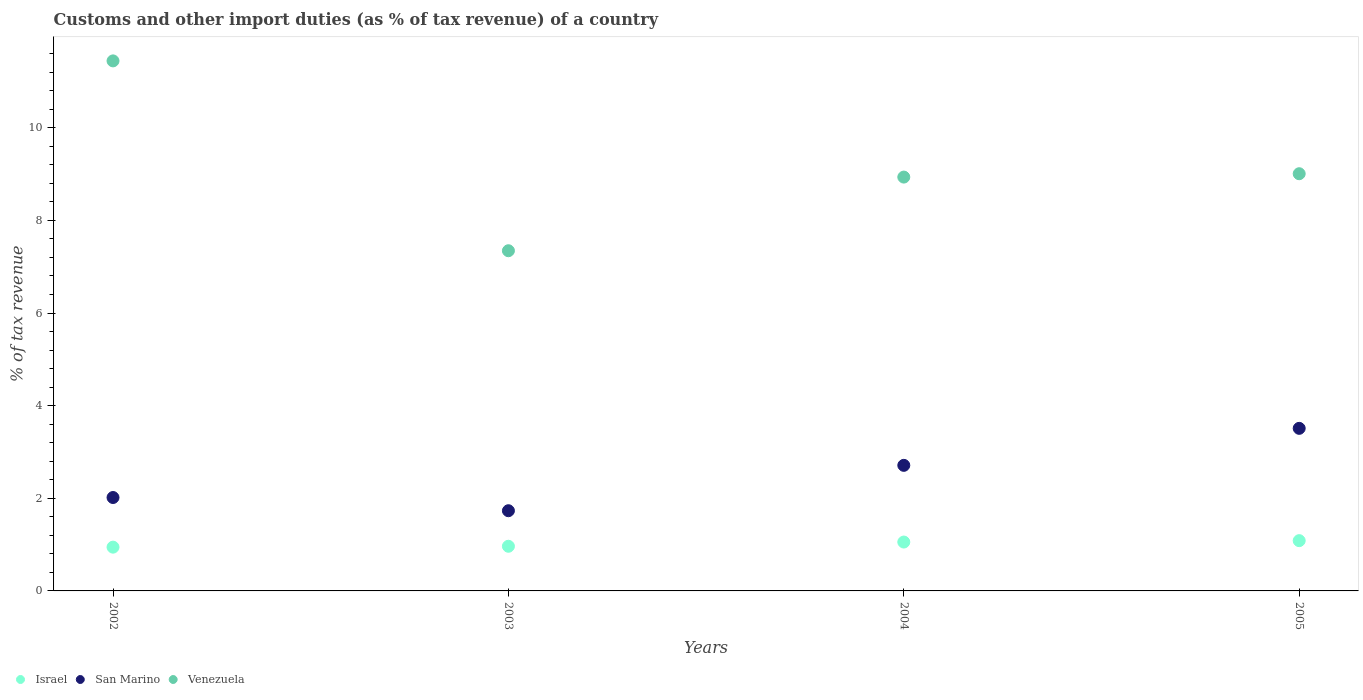What is the percentage of tax revenue from customs in Venezuela in 2005?
Your answer should be very brief. 9.01. Across all years, what is the maximum percentage of tax revenue from customs in Venezuela?
Keep it short and to the point. 11.44. Across all years, what is the minimum percentage of tax revenue from customs in San Marino?
Offer a very short reply. 1.73. What is the total percentage of tax revenue from customs in San Marino in the graph?
Offer a terse response. 9.97. What is the difference between the percentage of tax revenue from customs in Venezuela in 2002 and that in 2005?
Your answer should be compact. 2.44. What is the difference between the percentage of tax revenue from customs in San Marino in 2004 and the percentage of tax revenue from customs in Venezuela in 2002?
Provide a succinct answer. -8.73. What is the average percentage of tax revenue from customs in San Marino per year?
Keep it short and to the point. 2.49. In the year 2004, what is the difference between the percentage of tax revenue from customs in San Marino and percentage of tax revenue from customs in Venezuela?
Make the answer very short. -6.22. In how many years, is the percentage of tax revenue from customs in Venezuela greater than 6.4 %?
Provide a succinct answer. 4. What is the ratio of the percentage of tax revenue from customs in Venezuela in 2002 to that in 2005?
Ensure brevity in your answer.  1.27. What is the difference between the highest and the second highest percentage of tax revenue from customs in Venezuela?
Provide a succinct answer. 2.44. What is the difference between the highest and the lowest percentage of tax revenue from customs in Venezuela?
Your answer should be compact. 4.1. How many years are there in the graph?
Offer a very short reply. 4. What is the difference between two consecutive major ticks on the Y-axis?
Provide a short and direct response. 2. Are the values on the major ticks of Y-axis written in scientific E-notation?
Offer a very short reply. No. What is the title of the graph?
Make the answer very short. Customs and other import duties (as % of tax revenue) of a country. Does "Middle East & North Africa (developing only)" appear as one of the legend labels in the graph?
Your answer should be very brief. No. What is the label or title of the X-axis?
Your response must be concise. Years. What is the label or title of the Y-axis?
Keep it short and to the point. % of tax revenue. What is the % of tax revenue of Israel in 2002?
Keep it short and to the point. 0.95. What is the % of tax revenue of San Marino in 2002?
Provide a short and direct response. 2.02. What is the % of tax revenue in Venezuela in 2002?
Offer a very short reply. 11.44. What is the % of tax revenue in Israel in 2003?
Make the answer very short. 0.96. What is the % of tax revenue in San Marino in 2003?
Make the answer very short. 1.73. What is the % of tax revenue of Venezuela in 2003?
Offer a very short reply. 7.35. What is the % of tax revenue of Israel in 2004?
Provide a short and direct response. 1.06. What is the % of tax revenue of San Marino in 2004?
Offer a terse response. 2.71. What is the % of tax revenue in Venezuela in 2004?
Your answer should be compact. 8.94. What is the % of tax revenue of Israel in 2005?
Your response must be concise. 1.09. What is the % of tax revenue in San Marino in 2005?
Keep it short and to the point. 3.51. What is the % of tax revenue of Venezuela in 2005?
Offer a terse response. 9.01. Across all years, what is the maximum % of tax revenue of Israel?
Ensure brevity in your answer.  1.09. Across all years, what is the maximum % of tax revenue of San Marino?
Provide a short and direct response. 3.51. Across all years, what is the maximum % of tax revenue of Venezuela?
Offer a terse response. 11.44. Across all years, what is the minimum % of tax revenue in Israel?
Your answer should be compact. 0.95. Across all years, what is the minimum % of tax revenue in San Marino?
Offer a terse response. 1.73. Across all years, what is the minimum % of tax revenue of Venezuela?
Provide a short and direct response. 7.35. What is the total % of tax revenue in Israel in the graph?
Make the answer very short. 4.05. What is the total % of tax revenue of San Marino in the graph?
Your response must be concise. 9.97. What is the total % of tax revenue of Venezuela in the graph?
Offer a very short reply. 36.73. What is the difference between the % of tax revenue of Israel in 2002 and that in 2003?
Your response must be concise. -0.02. What is the difference between the % of tax revenue of San Marino in 2002 and that in 2003?
Your answer should be compact. 0.29. What is the difference between the % of tax revenue of Venezuela in 2002 and that in 2003?
Your answer should be very brief. 4.1. What is the difference between the % of tax revenue of Israel in 2002 and that in 2004?
Ensure brevity in your answer.  -0.11. What is the difference between the % of tax revenue in San Marino in 2002 and that in 2004?
Provide a short and direct response. -0.69. What is the difference between the % of tax revenue in Venezuela in 2002 and that in 2004?
Your response must be concise. 2.51. What is the difference between the % of tax revenue in Israel in 2002 and that in 2005?
Your answer should be very brief. -0.14. What is the difference between the % of tax revenue of San Marino in 2002 and that in 2005?
Make the answer very short. -1.49. What is the difference between the % of tax revenue in Venezuela in 2002 and that in 2005?
Keep it short and to the point. 2.44. What is the difference between the % of tax revenue of Israel in 2003 and that in 2004?
Keep it short and to the point. -0.09. What is the difference between the % of tax revenue in San Marino in 2003 and that in 2004?
Provide a succinct answer. -0.98. What is the difference between the % of tax revenue in Venezuela in 2003 and that in 2004?
Ensure brevity in your answer.  -1.59. What is the difference between the % of tax revenue in Israel in 2003 and that in 2005?
Your response must be concise. -0.12. What is the difference between the % of tax revenue in San Marino in 2003 and that in 2005?
Provide a succinct answer. -1.78. What is the difference between the % of tax revenue of Venezuela in 2003 and that in 2005?
Ensure brevity in your answer.  -1.66. What is the difference between the % of tax revenue of Israel in 2004 and that in 2005?
Offer a very short reply. -0.03. What is the difference between the % of tax revenue in San Marino in 2004 and that in 2005?
Provide a short and direct response. -0.8. What is the difference between the % of tax revenue in Venezuela in 2004 and that in 2005?
Ensure brevity in your answer.  -0.07. What is the difference between the % of tax revenue of Israel in 2002 and the % of tax revenue of San Marino in 2003?
Your answer should be compact. -0.79. What is the difference between the % of tax revenue of Israel in 2002 and the % of tax revenue of Venezuela in 2003?
Your response must be concise. -6.4. What is the difference between the % of tax revenue of San Marino in 2002 and the % of tax revenue of Venezuela in 2003?
Your answer should be very brief. -5.33. What is the difference between the % of tax revenue of Israel in 2002 and the % of tax revenue of San Marino in 2004?
Offer a terse response. -1.77. What is the difference between the % of tax revenue of Israel in 2002 and the % of tax revenue of Venezuela in 2004?
Offer a very short reply. -7.99. What is the difference between the % of tax revenue of San Marino in 2002 and the % of tax revenue of Venezuela in 2004?
Your answer should be compact. -6.92. What is the difference between the % of tax revenue in Israel in 2002 and the % of tax revenue in San Marino in 2005?
Make the answer very short. -2.57. What is the difference between the % of tax revenue in Israel in 2002 and the % of tax revenue in Venezuela in 2005?
Give a very brief answer. -8.06. What is the difference between the % of tax revenue in San Marino in 2002 and the % of tax revenue in Venezuela in 2005?
Keep it short and to the point. -6.99. What is the difference between the % of tax revenue of Israel in 2003 and the % of tax revenue of San Marino in 2004?
Offer a terse response. -1.75. What is the difference between the % of tax revenue in Israel in 2003 and the % of tax revenue in Venezuela in 2004?
Your response must be concise. -7.97. What is the difference between the % of tax revenue of San Marino in 2003 and the % of tax revenue of Venezuela in 2004?
Offer a very short reply. -7.2. What is the difference between the % of tax revenue of Israel in 2003 and the % of tax revenue of San Marino in 2005?
Offer a very short reply. -2.55. What is the difference between the % of tax revenue in Israel in 2003 and the % of tax revenue in Venezuela in 2005?
Provide a short and direct response. -8.04. What is the difference between the % of tax revenue of San Marino in 2003 and the % of tax revenue of Venezuela in 2005?
Your answer should be very brief. -7.28. What is the difference between the % of tax revenue of Israel in 2004 and the % of tax revenue of San Marino in 2005?
Make the answer very short. -2.46. What is the difference between the % of tax revenue in Israel in 2004 and the % of tax revenue in Venezuela in 2005?
Provide a succinct answer. -7.95. What is the difference between the % of tax revenue of San Marino in 2004 and the % of tax revenue of Venezuela in 2005?
Keep it short and to the point. -6.3. What is the average % of tax revenue of Israel per year?
Keep it short and to the point. 1.01. What is the average % of tax revenue in San Marino per year?
Offer a very short reply. 2.49. What is the average % of tax revenue of Venezuela per year?
Provide a succinct answer. 9.18. In the year 2002, what is the difference between the % of tax revenue of Israel and % of tax revenue of San Marino?
Keep it short and to the point. -1.07. In the year 2002, what is the difference between the % of tax revenue in Israel and % of tax revenue in Venezuela?
Your answer should be compact. -10.5. In the year 2002, what is the difference between the % of tax revenue in San Marino and % of tax revenue in Venezuela?
Provide a succinct answer. -9.43. In the year 2003, what is the difference between the % of tax revenue in Israel and % of tax revenue in San Marino?
Offer a very short reply. -0.77. In the year 2003, what is the difference between the % of tax revenue in Israel and % of tax revenue in Venezuela?
Provide a short and direct response. -6.38. In the year 2003, what is the difference between the % of tax revenue in San Marino and % of tax revenue in Venezuela?
Ensure brevity in your answer.  -5.61. In the year 2004, what is the difference between the % of tax revenue of Israel and % of tax revenue of San Marino?
Offer a terse response. -1.66. In the year 2004, what is the difference between the % of tax revenue of Israel and % of tax revenue of Venezuela?
Give a very brief answer. -7.88. In the year 2004, what is the difference between the % of tax revenue of San Marino and % of tax revenue of Venezuela?
Your answer should be compact. -6.22. In the year 2005, what is the difference between the % of tax revenue of Israel and % of tax revenue of San Marino?
Your answer should be compact. -2.42. In the year 2005, what is the difference between the % of tax revenue in Israel and % of tax revenue in Venezuela?
Give a very brief answer. -7.92. In the year 2005, what is the difference between the % of tax revenue in San Marino and % of tax revenue in Venezuela?
Give a very brief answer. -5.5. What is the ratio of the % of tax revenue of Israel in 2002 to that in 2003?
Your answer should be compact. 0.98. What is the ratio of the % of tax revenue of San Marino in 2002 to that in 2003?
Ensure brevity in your answer.  1.16. What is the ratio of the % of tax revenue of Venezuela in 2002 to that in 2003?
Your response must be concise. 1.56. What is the ratio of the % of tax revenue in Israel in 2002 to that in 2004?
Make the answer very short. 0.9. What is the ratio of the % of tax revenue of San Marino in 2002 to that in 2004?
Give a very brief answer. 0.74. What is the ratio of the % of tax revenue of Venezuela in 2002 to that in 2004?
Your response must be concise. 1.28. What is the ratio of the % of tax revenue in Israel in 2002 to that in 2005?
Provide a succinct answer. 0.87. What is the ratio of the % of tax revenue in San Marino in 2002 to that in 2005?
Your response must be concise. 0.57. What is the ratio of the % of tax revenue in Venezuela in 2002 to that in 2005?
Make the answer very short. 1.27. What is the ratio of the % of tax revenue in Israel in 2003 to that in 2004?
Ensure brevity in your answer.  0.91. What is the ratio of the % of tax revenue in San Marino in 2003 to that in 2004?
Ensure brevity in your answer.  0.64. What is the ratio of the % of tax revenue of Venezuela in 2003 to that in 2004?
Provide a short and direct response. 0.82. What is the ratio of the % of tax revenue of Israel in 2003 to that in 2005?
Give a very brief answer. 0.89. What is the ratio of the % of tax revenue in San Marino in 2003 to that in 2005?
Ensure brevity in your answer.  0.49. What is the ratio of the % of tax revenue of Venezuela in 2003 to that in 2005?
Provide a succinct answer. 0.82. What is the ratio of the % of tax revenue of Israel in 2004 to that in 2005?
Keep it short and to the point. 0.97. What is the ratio of the % of tax revenue in San Marino in 2004 to that in 2005?
Your answer should be very brief. 0.77. What is the difference between the highest and the second highest % of tax revenue of Israel?
Provide a succinct answer. 0.03. What is the difference between the highest and the second highest % of tax revenue in San Marino?
Offer a terse response. 0.8. What is the difference between the highest and the second highest % of tax revenue of Venezuela?
Keep it short and to the point. 2.44. What is the difference between the highest and the lowest % of tax revenue in Israel?
Provide a short and direct response. 0.14. What is the difference between the highest and the lowest % of tax revenue of San Marino?
Your answer should be very brief. 1.78. What is the difference between the highest and the lowest % of tax revenue in Venezuela?
Give a very brief answer. 4.1. 